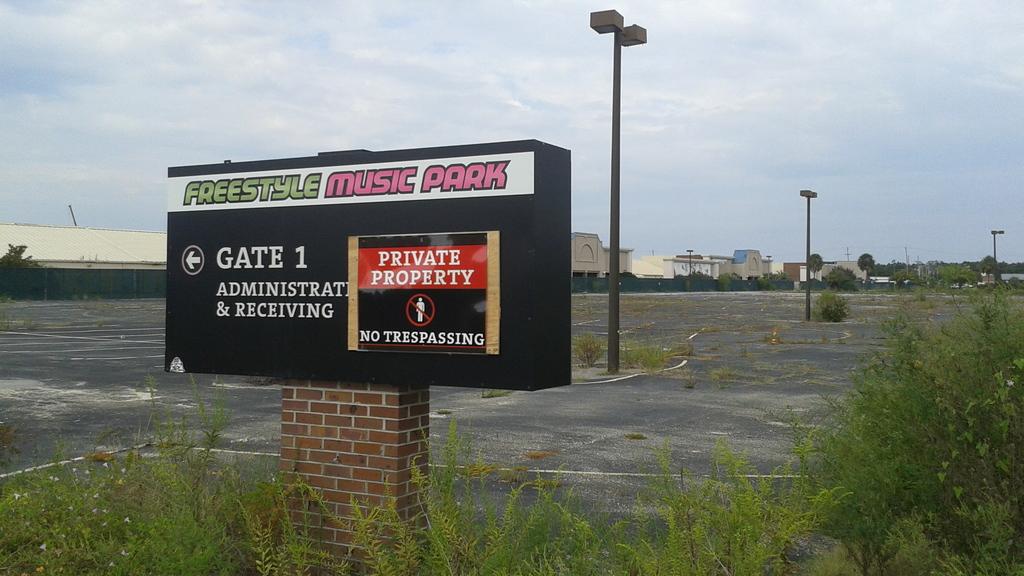What type of property is this?
Keep it short and to the point. Private. 